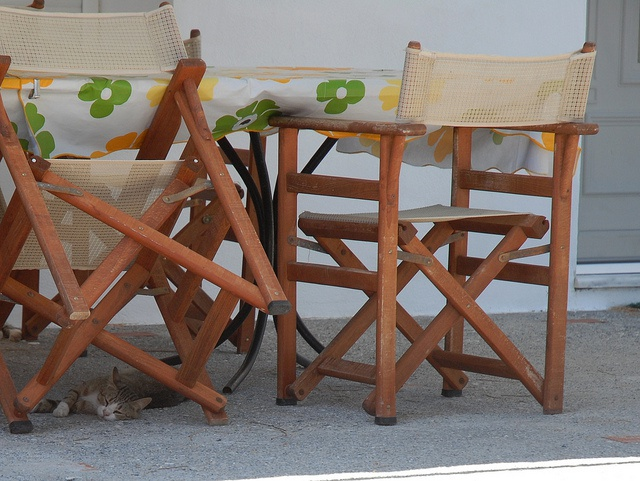Describe the objects in this image and their specific colors. I can see chair in gray, darkgray, maroon, and brown tones, chair in gray, darkgray, maroon, and brown tones, dining table in gray, darkgray, darkgreen, and tan tones, cat in gray and black tones, and chair in gray, maroon, and darkgray tones in this image. 